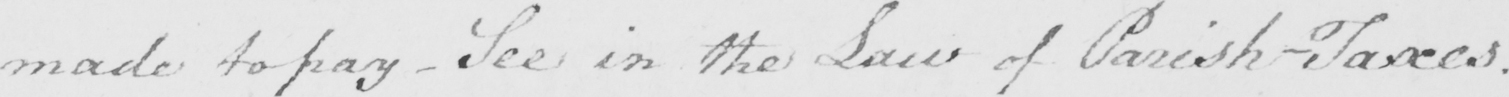Transcribe the text shown in this historical manuscript line. made to pay - See in the Law of Parish Taxes . 